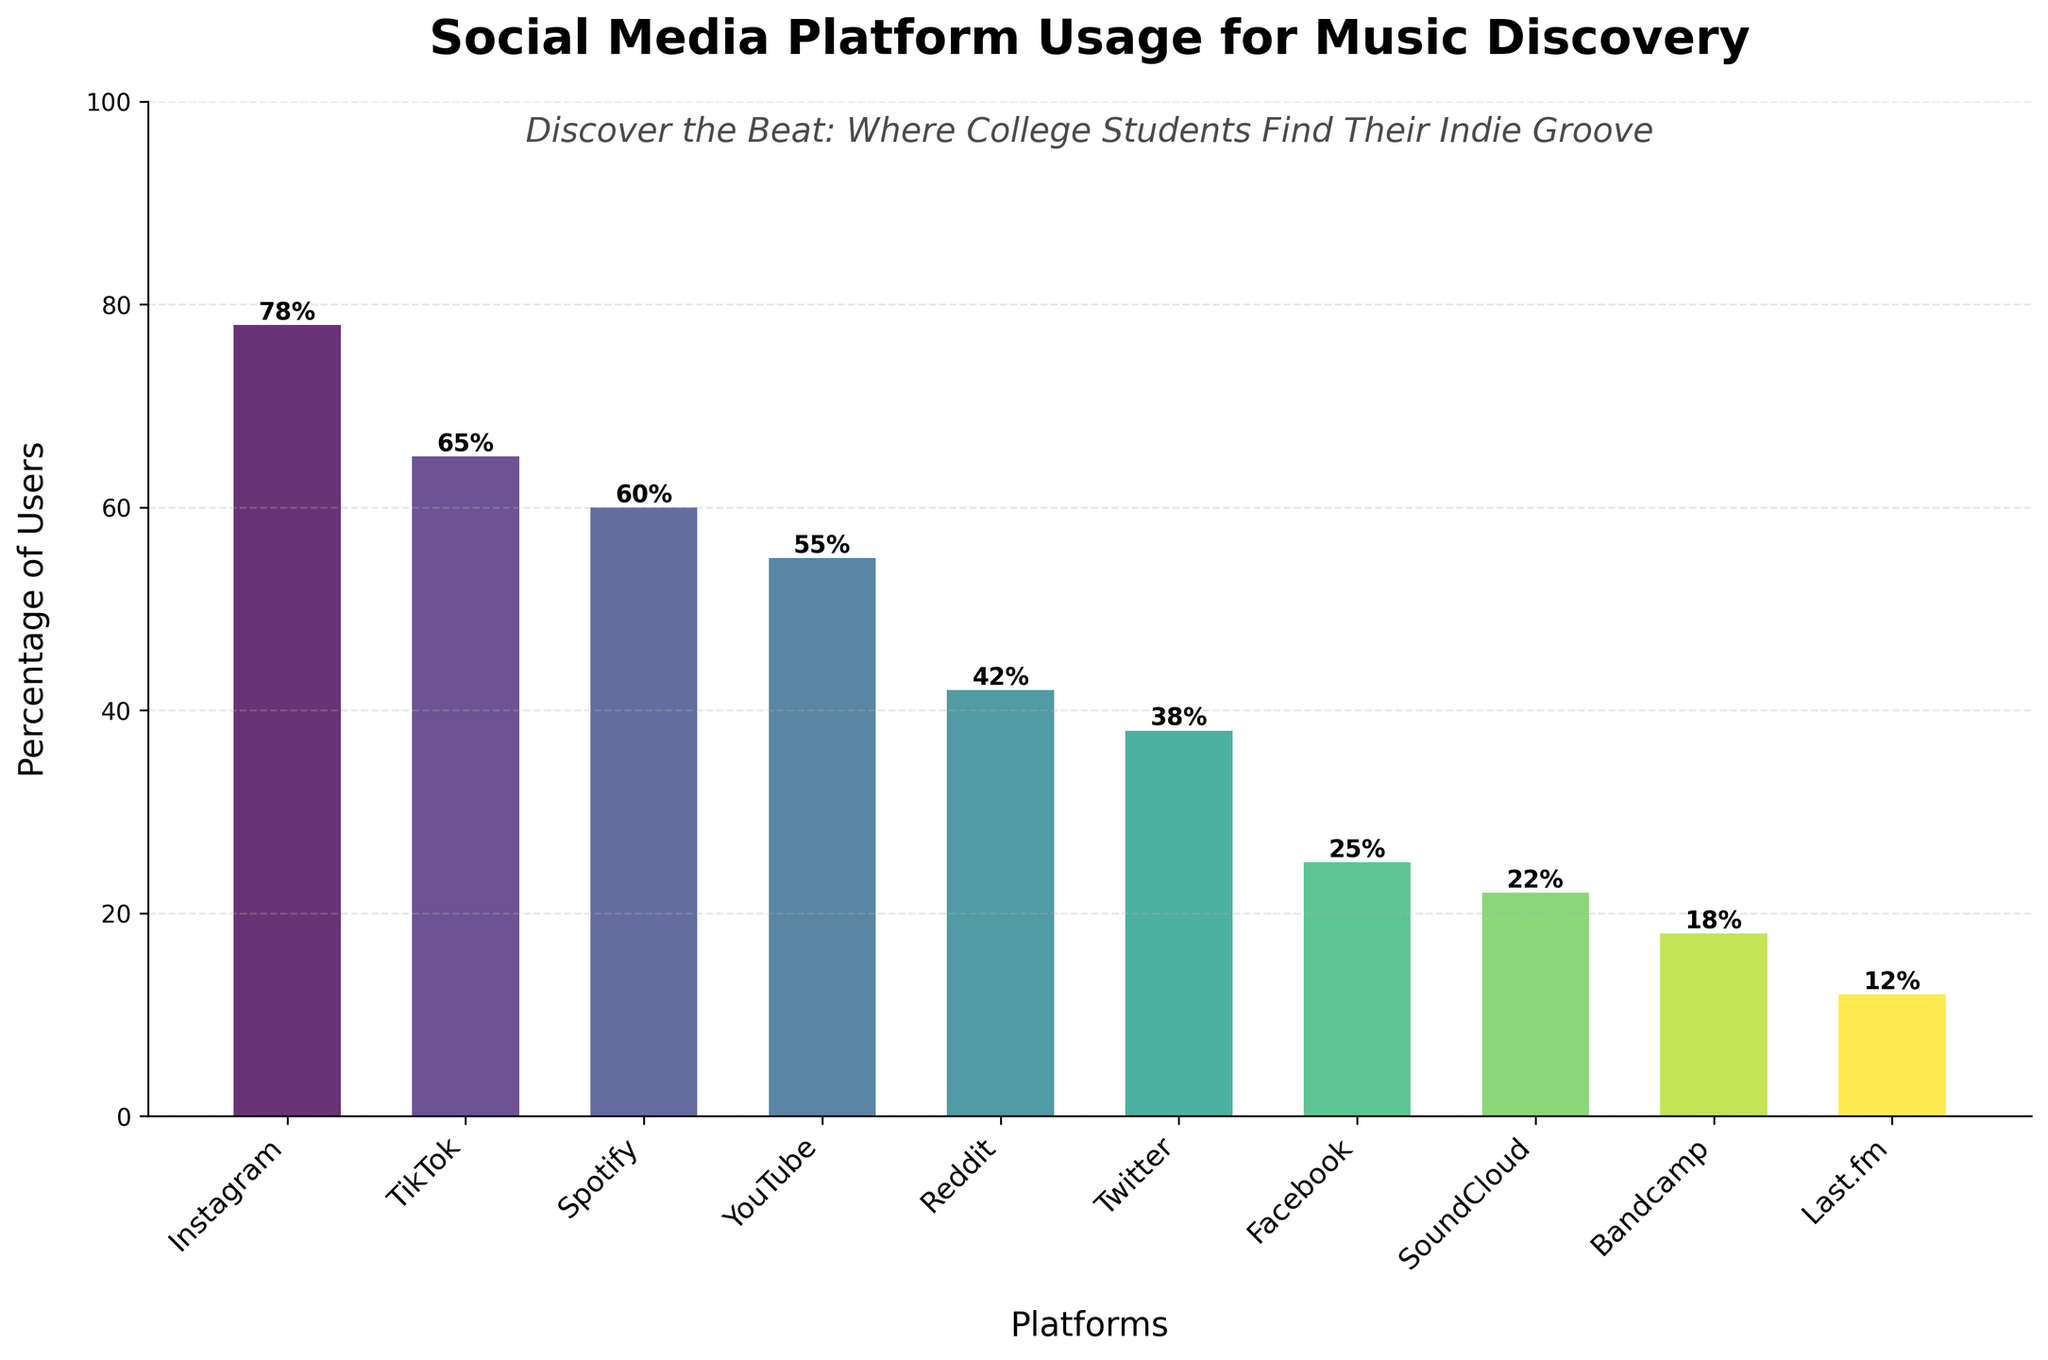What are the top three platforms used for music discovery among college students? Look at the top three bars in the chart. The platforms corresponding to these are the ones with the highest percentages.
Answer: Instagram, TikTok, Spotify Which platform has the lowest percentage of users for music discovery? Look at the shortest bar in the chart. The platform with this bar has the lowest percentage.
Answer: Last.fm Which platform is more popular for music discovery: YouTube or Reddit? Compare the height of the bars for YouTube and Reddit. The taller bar represents the more popular platform.
Answer: YouTube How much more popular is Instagram compared to SoundCloud? Find the heights of the bars for Instagram and SoundCloud. Subtract the percentage for SoundCloud from the percentage for Instagram.
Answer: 56% Is TikTok used by more than half of the college student population for music discovery? Look at the percentage value for TikTok and check if it is greater than 50.
Answer: Yes If you combined the percentages of Facebook and Bandcamp, would they surpass the percentage of YouTube? Add the percentages of Facebook and Bandcamp: 25 + 18 = 43. Compare this sum to the percentage for YouTube.
Answer: No Which platform is closer in percentage to Spotify: TikTok or YouTube? Compare the differences: TikTok is 5% more than Spotify, and YouTube is 5% less. Both are equally close.
Answer: Both What is the total percentage of users who use either Reddit, Twitter, or Facebook for music discovery? Add the percentages for Reddit, Twitter, and Facebook: 42 + 38 + 25 = 105.
Answer: 105% What is the range of usage percentages across all platforms? Find the difference between the highest percentage (Instagram) and the lowest percentage (Last.fm). 78 - 12 = 66.
Answer: 66% On which platform do less than 20% of college students discover music? Identify the platforms with bars below the 20% mark: SoundCloud (22%) is above 20%, so only Bandcamp (18%) and Last.fm (12%) are below 20%.
Answer: Bandcamp, Last.fm 